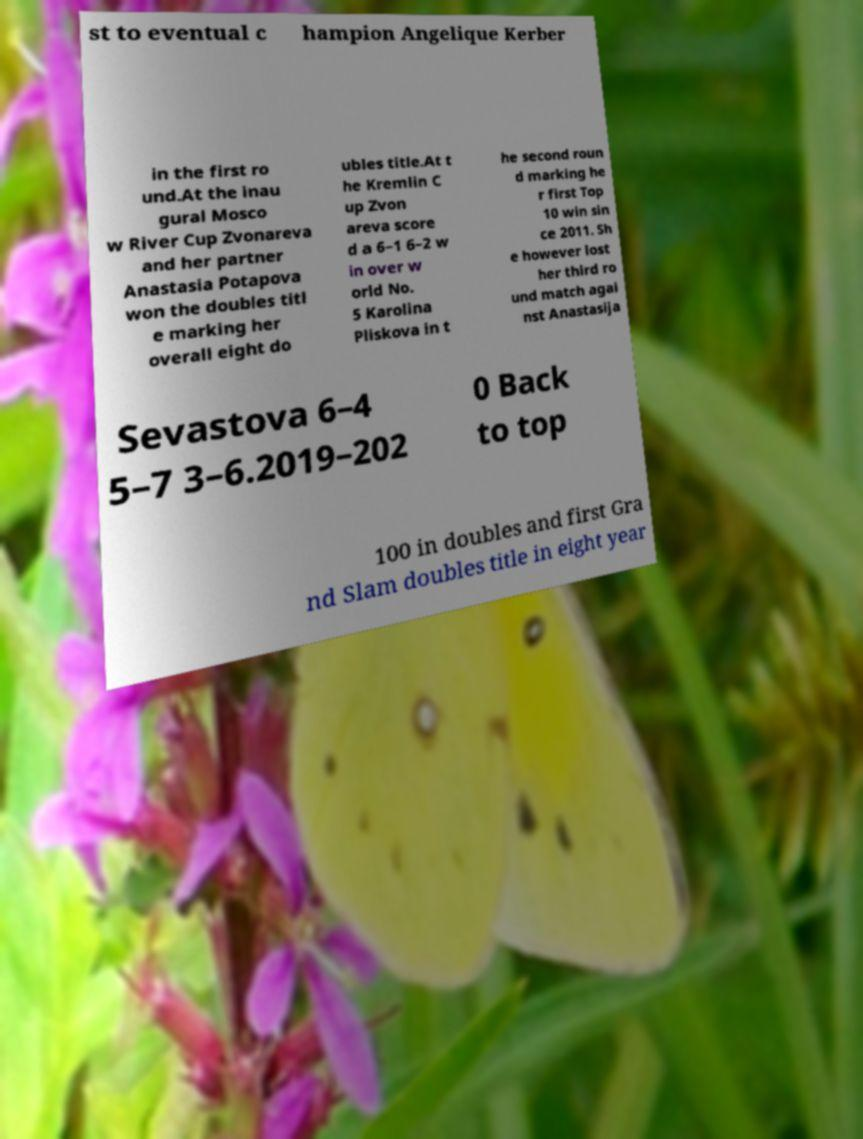Can you accurately transcribe the text from the provided image for me? st to eventual c hampion Angelique Kerber in the first ro und.At the inau gural Mosco w River Cup Zvonareva and her partner Anastasia Potapova won the doubles titl e marking her overall eight do ubles title.At t he Kremlin C up Zvon areva score d a 6–1 6–2 w in over w orld No. 5 Karolina Pliskova in t he second roun d marking he r first Top 10 win sin ce 2011. Sh e however lost her third ro und match agai nst Anastasija Sevastova 6–4 5–7 3–6.2019–202 0 Back to top 100 in doubles and first Gra nd Slam doubles title in eight year 